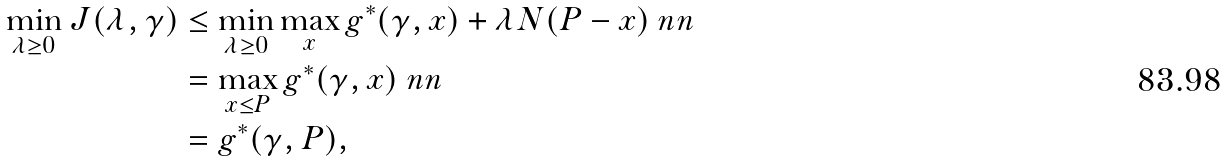<formula> <loc_0><loc_0><loc_500><loc_500>\min _ { \lambda \geq 0 } J ( \lambda , \gamma ) & \leq \min _ { \lambda \geq 0 } \max _ { x } g ^ { * } ( \gamma , x ) + \lambda N ( P - x ) \ n n \\ & = \max _ { x \leq P } g ^ { * } ( \gamma , x ) \ n n \\ & = g ^ { * } ( \gamma , P ) ,</formula> 